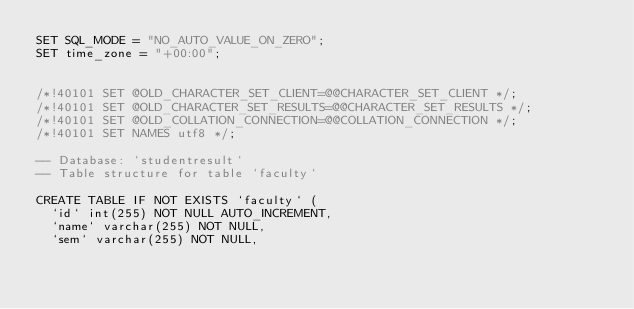Convert code to text. <code><loc_0><loc_0><loc_500><loc_500><_SQL_>SET SQL_MODE = "NO_AUTO_VALUE_ON_ZERO";
SET time_zone = "+00:00";


/*!40101 SET @OLD_CHARACTER_SET_CLIENT=@@CHARACTER_SET_CLIENT */;
/*!40101 SET @OLD_CHARACTER_SET_RESULTS=@@CHARACTER_SET_RESULTS */;
/*!40101 SET @OLD_COLLATION_CONNECTION=@@COLLATION_CONNECTION */;
/*!40101 SET NAMES utf8 */;

-- Database: `studentresult`
-- Table structure for table `faculty`

CREATE TABLE IF NOT EXISTS `faculty` (
  `id` int(255) NOT NULL AUTO_INCREMENT,
  `name` varchar(255) NOT NULL,
  `sem` varchar(255) NOT NULL,</code> 